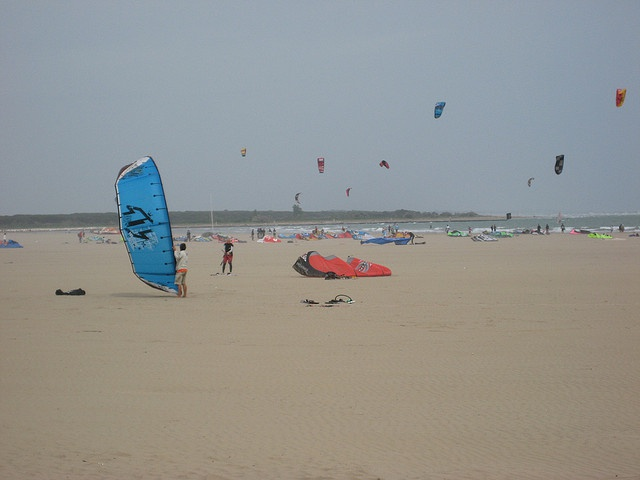Describe the objects in this image and their specific colors. I can see kite in darkgray, teal, blue, and black tones, kite in darkgray, brown, and gray tones, people in darkgray and gray tones, boat in darkgray, gray, and blue tones, and people in darkgray, black, gray, and maroon tones in this image. 